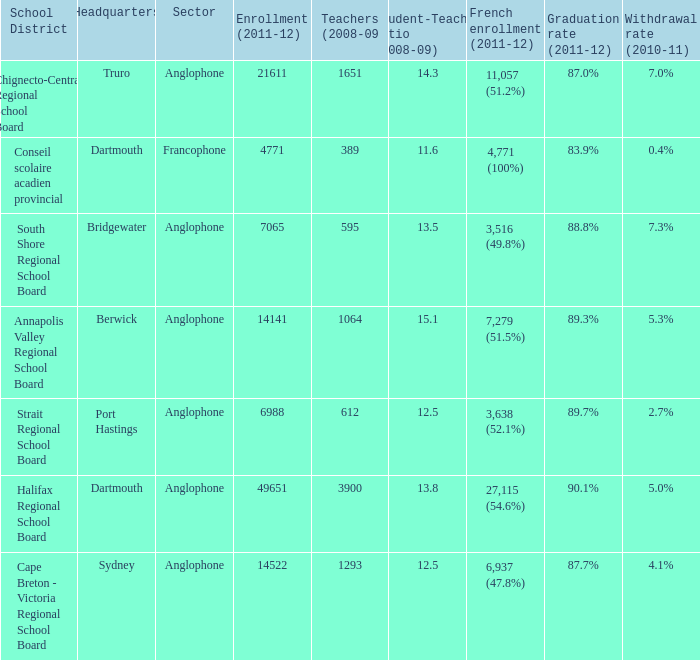What is their withdrawal rate for the school district with headquarters located in Truro? 7.0%. 